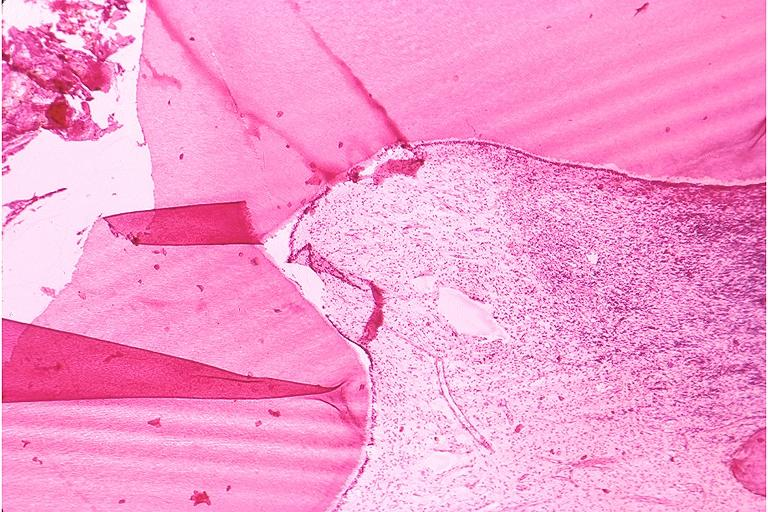s oral present?
Answer the question using a single word or phrase. Yes 